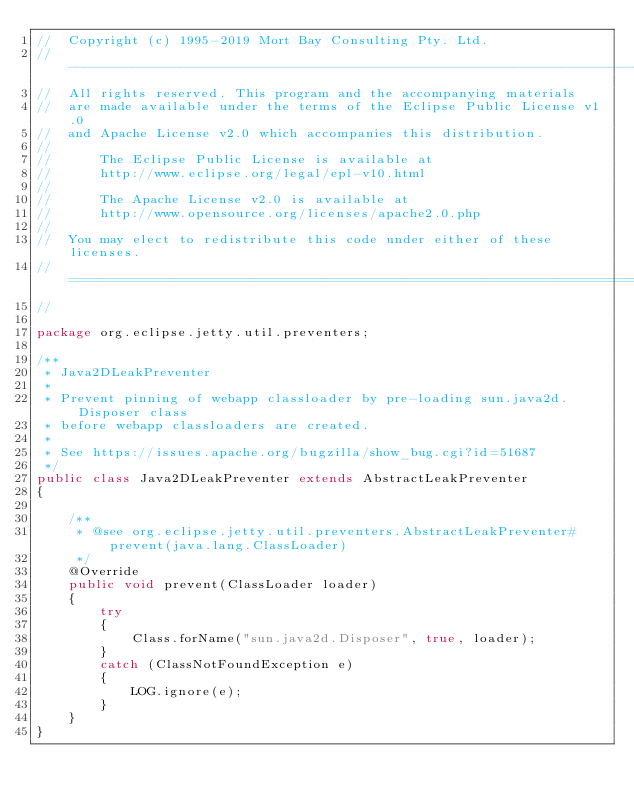Convert code to text. <code><loc_0><loc_0><loc_500><loc_500><_Java_>//  Copyright (c) 1995-2019 Mort Bay Consulting Pty. Ltd.
//  ------------------------------------------------------------------------
//  All rights reserved. This program and the accompanying materials
//  are made available under the terms of the Eclipse Public License v1.0
//  and Apache License v2.0 which accompanies this distribution.
//
//      The Eclipse Public License is available at
//      http://www.eclipse.org/legal/epl-v10.html
//
//      The Apache License v2.0 is available at
//      http://www.opensource.org/licenses/apache2.0.php
//
//  You may elect to redistribute this code under either of these licenses.
//  ========================================================================
//

package org.eclipse.jetty.util.preventers;

/**
 * Java2DLeakPreventer
 *
 * Prevent pinning of webapp classloader by pre-loading sun.java2d.Disposer class
 * before webapp classloaders are created.
 *
 * See https://issues.apache.org/bugzilla/show_bug.cgi?id=51687
 */
public class Java2DLeakPreventer extends AbstractLeakPreventer
{

    /**
     * @see org.eclipse.jetty.util.preventers.AbstractLeakPreventer#prevent(java.lang.ClassLoader)
     */
    @Override
    public void prevent(ClassLoader loader)
    {
        try
        {
            Class.forName("sun.java2d.Disposer", true, loader);
        }
        catch (ClassNotFoundException e)
        {
            LOG.ignore(e);
        }
    }
}
</code> 